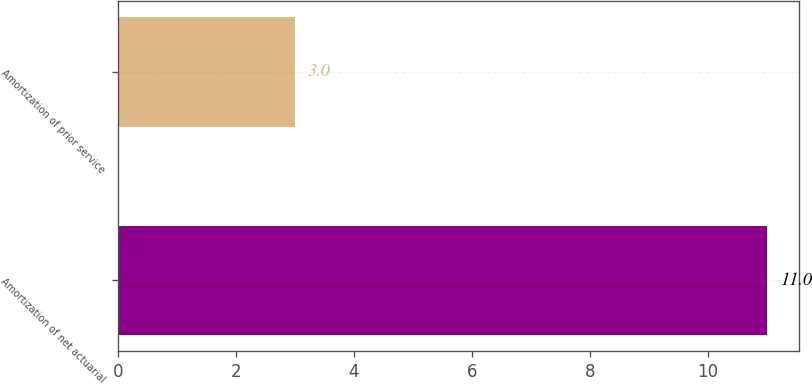Convert chart. <chart><loc_0><loc_0><loc_500><loc_500><bar_chart><fcel>Amortization of net actuarial<fcel>Amortization of prior service<nl><fcel>11<fcel>3<nl></chart> 